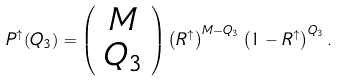<formula> <loc_0><loc_0><loc_500><loc_500>P ^ { \uparrow } ( Q _ { 3 } ) = \left ( \begin{array} { c } M \\ Q _ { 3 } \end{array} \right ) \left ( R ^ { \uparrow } \right ) ^ { M - Q _ { 3 } } \left ( 1 - R ^ { \uparrow } \right ) ^ { Q _ { 3 } } .</formula> 